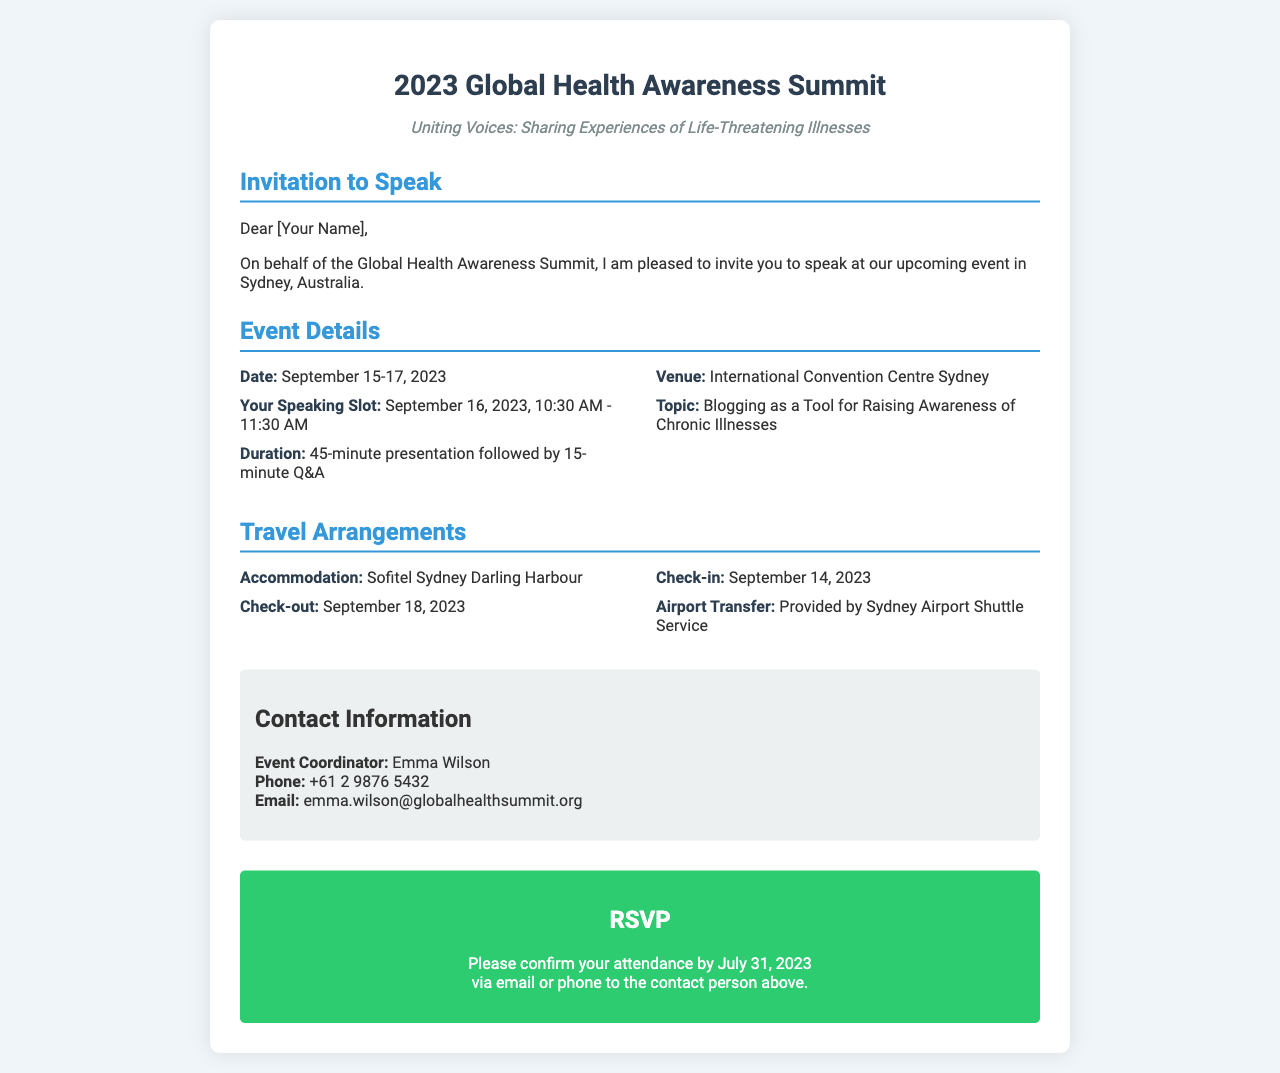what is the date of the event? The event takes place over three days from September 15 to September 17, 2023.
Answer: September 15-17, 2023 who is the event coordinator? The event coordinator is responsible for managing event details and attendees. In this document, her name is mentioned.
Answer: Emma Wilson what is the topic of the presentation? The topic for the invited speaker is indicated in the document as part of the event details.
Answer: Blogging as a Tool for Raising Awareness of Chronic Illnesses what is the duration of the speaking slot? The duration of the presentation is specified, which includes both the presentation and the Q&A session.
Answer: 45-minute presentation followed by 15-minute Q&A what is the check-in date for accommodation? The check-in date is provided in the travel arrangements section.
Answer: September 14, 2023 what is the venue for the summit? The venue is specified and is a recognized location for large events.
Answer: International Convention Centre Sydney how should attendees confirm their attendance? The document outlines the RSVP process for confirming attendance.
Answer: via email or phone what transportation service is provided for airport transfer? The document specifies the type of service that will arrange transport from the airport.
Answer: Sydney Airport Shuttle Service 